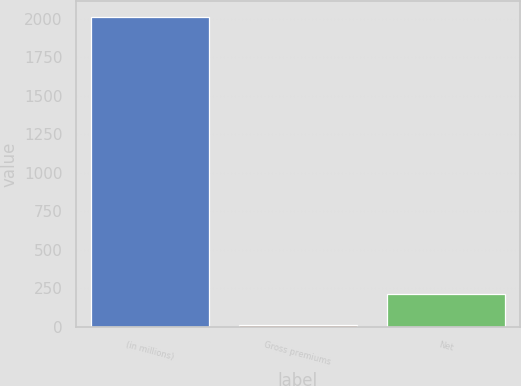<chart> <loc_0><loc_0><loc_500><loc_500><bar_chart><fcel>(in millions)<fcel>Gross premiums<fcel>Net<nl><fcel>2013<fcel>9<fcel>209.4<nl></chart> 